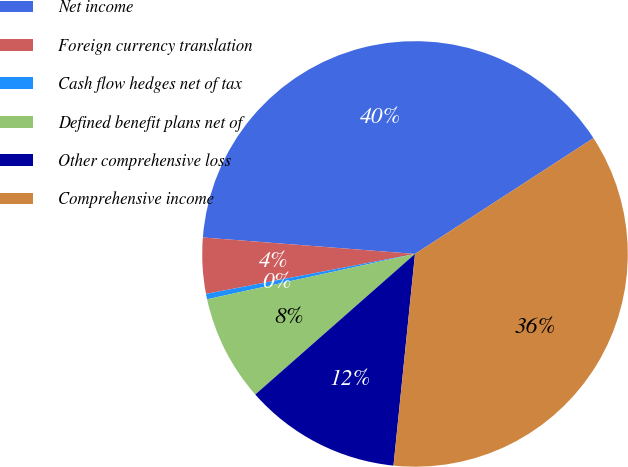Convert chart to OTSL. <chart><loc_0><loc_0><loc_500><loc_500><pie_chart><fcel>Net income<fcel>Foreign currency translation<fcel>Cash flow hedges net of tax<fcel>Defined benefit plans net of<fcel>Other comprehensive loss<fcel>Comprehensive income<nl><fcel>39.6%<fcel>4.24%<fcel>0.41%<fcel>8.07%<fcel>11.9%<fcel>35.77%<nl></chart> 